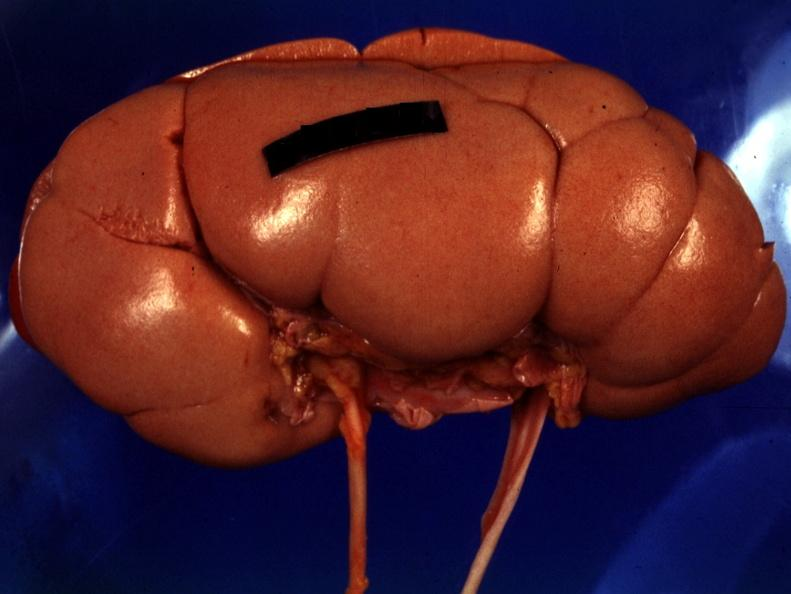what does this image show?
Answer the question using a single word or phrase. Good photo except for reflected lights 